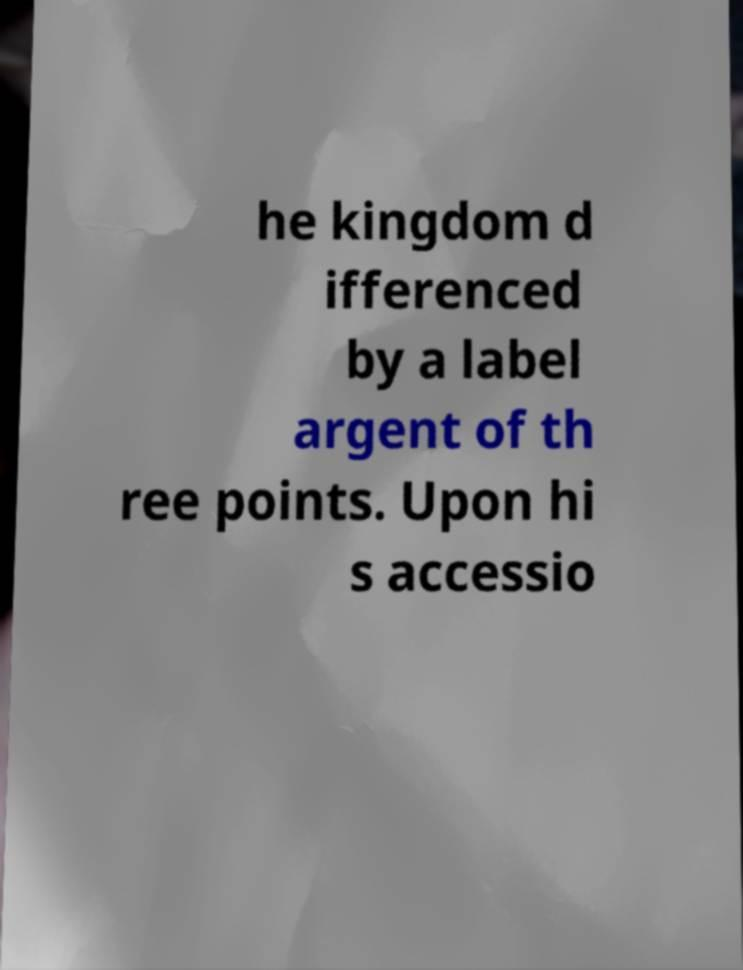Could you assist in decoding the text presented in this image and type it out clearly? he kingdom d ifferenced by a label argent of th ree points. Upon hi s accessio 